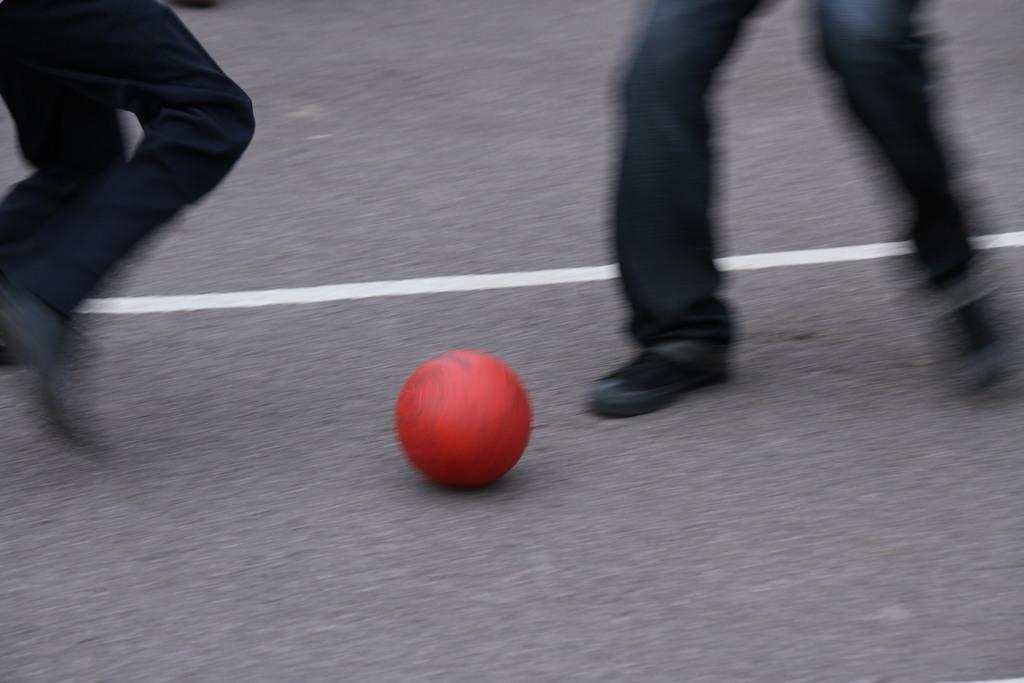How many people are in the image? There are two persons in the image. What are the two persons doing in the image? The two persons are trying to kick a ball. Where is the ball located in the image? The ball is on a surface. What type of drawer can be seen in the image? There is no drawer present in the image. How does the earth play a role in the image? The image does not depict the earth or any related activities. 